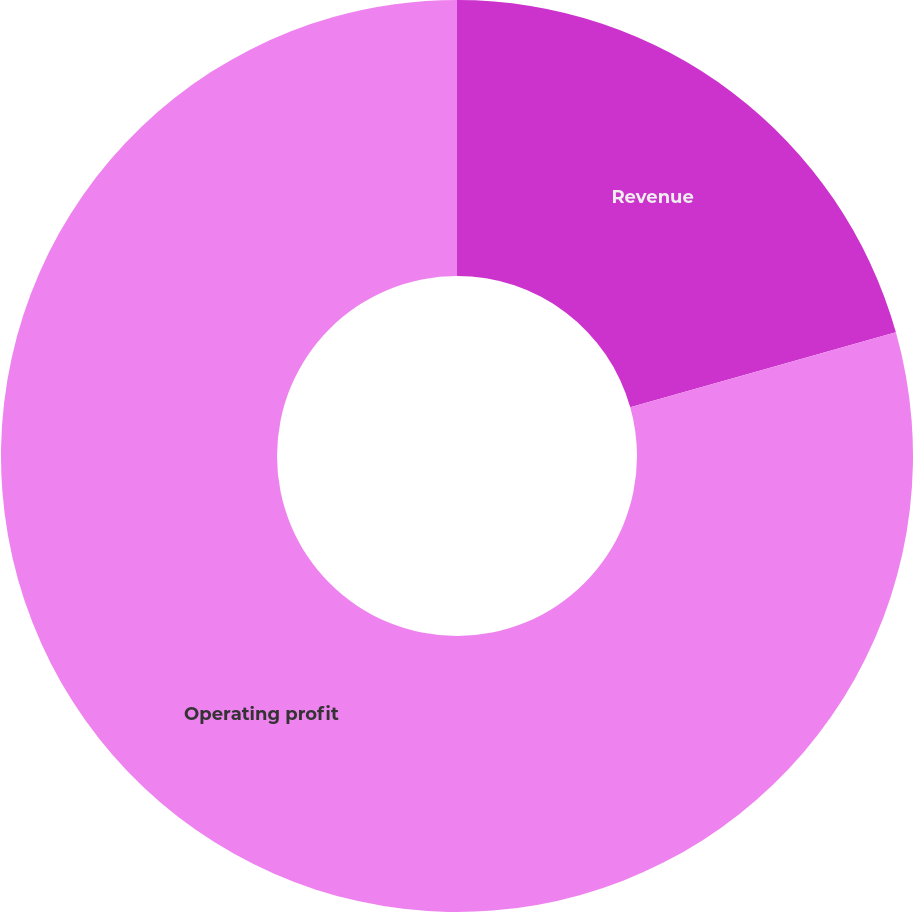Convert chart to OTSL. <chart><loc_0><loc_0><loc_500><loc_500><pie_chart><fcel>Revenue<fcel>Operating profit<nl><fcel>20.63%<fcel>79.37%<nl></chart> 